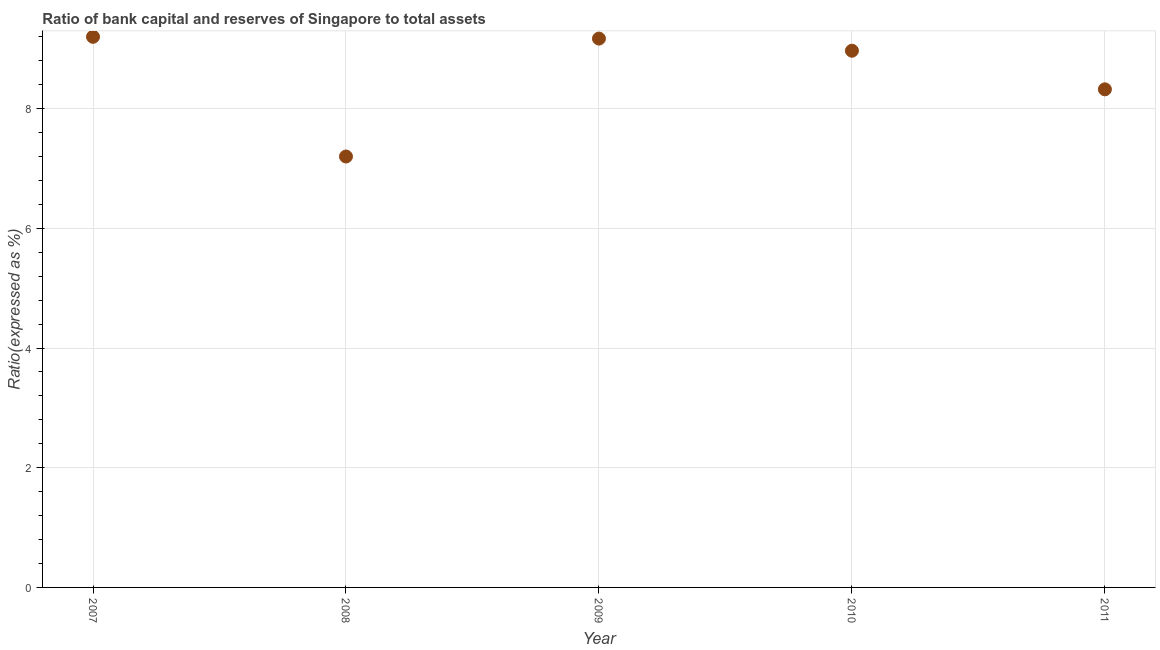What is the bank capital to assets ratio in 2007?
Make the answer very short. 9.2. Across all years, what is the maximum bank capital to assets ratio?
Ensure brevity in your answer.  9.2. Across all years, what is the minimum bank capital to assets ratio?
Give a very brief answer. 7.2. In which year was the bank capital to assets ratio maximum?
Provide a short and direct response. 2007. In which year was the bank capital to assets ratio minimum?
Your answer should be very brief. 2008. What is the sum of the bank capital to assets ratio?
Provide a short and direct response. 42.86. What is the difference between the bank capital to assets ratio in 2009 and 2010?
Make the answer very short. 0.2. What is the average bank capital to assets ratio per year?
Provide a succinct answer. 8.57. What is the median bank capital to assets ratio?
Make the answer very short. 8.97. Do a majority of the years between 2009 and 2010 (inclusive) have bank capital to assets ratio greater than 1.2000000000000002 %?
Offer a very short reply. Yes. What is the ratio of the bank capital to assets ratio in 2009 to that in 2011?
Your answer should be very brief. 1.1. Is the bank capital to assets ratio in 2008 less than that in 2011?
Your answer should be very brief. Yes. What is the difference between the highest and the second highest bank capital to assets ratio?
Keep it short and to the point. 0.03. What is the difference between the highest and the lowest bank capital to assets ratio?
Ensure brevity in your answer.  2. In how many years, is the bank capital to assets ratio greater than the average bank capital to assets ratio taken over all years?
Provide a succinct answer. 3. Does the bank capital to assets ratio monotonically increase over the years?
Give a very brief answer. No. What is the difference between two consecutive major ticks on the Y-axis?
Provide a succinct answer. 2. Are the values on the major ticks of Y-axis written in scientific E-notation?
Your response must be concise. No. What is the title of the graph?
Keep it short and to the point. Ratio of bank capital and reserves of Singapore to total assets. What is the label or title of the Y-axis?
Offer a very short reply. Ratio(expressed as %). What is the Ratio(expressed as %) in 2008?
Make the answer very short. 7.2. What is the Ratio(expressed as %) in 2009?
Give a very brief answer. 9.17. What is the Ratio(expressed as %) in 2010?
Your answer should be compact. 8.97. What is the Ratio(expressed as %) in 2011?
Ensure brevity in your answer.  8.32. What is the difference between the Ratio(expressed as %) in 2007 and 2009?
Provide a succinct answer. 0.03. What is the difference between the Ratio(expressed as %) in 2007 and 2010?
Give a very brief answer. 0.23. What is the difference between the Ratio(expressed as %) in 2007 and 2011?
Keep it short and to the point. 0.88. What is the difference between the Ratio(expressed as %) in 2008 and 2009?
Offer a very short reply. -1.97. What is the difference between the Ratio(expressed as %) in 2008 and 2010?
Offer a very short reply. -1.77. What is the difference between the Ratio(expressed as %) in 2008 and 2011?
Your answer should be compact. -1.12. What is the difference between the Ratio(expressed as %) in 2009 and 2010?
Your answer should be compact. 0.2. What is the difference between the Ratio(expressed as %) in 2009 and 2011?
Offer a terse response. 0.85. What is the difference between the Ratio(expressed as %) in 2010 and 2011?
Give a very brief answer. 0.65. What is the ratio of the Ratio(expressed as %) in 2007 to that in 2008?
Offer a terse response. 1.28. What is the ratio of the Ratio(expressed as %) in 2007 to that in 2009?
Make the answer very short. 1. What is the ratio of the Ratio(expressed as %) in 2007 to that in 2011?
Provide a succinct answer. 1.1. What is the ratio of the Ratio(expressed as %) in 2008 to that in 2009?
Your answer should be very brief. 0.79. What is the ratio of the Ratio(expressed as %) in 2008 to that in 2010?
Your response must be concise. 0.8. What is the ratio of the Ratio(expressed as %) in 2008 to that in 2011?
Offer a terse response. 0.86. What is the ratio of the Ratio(expressed as %) in 2009 to that in 2011?
Offer a terse response. 1.1. What is the ratio of the Ratio(expressed as %) in 2010 to that in 2011?
Offer a very short reply. 1.08. 